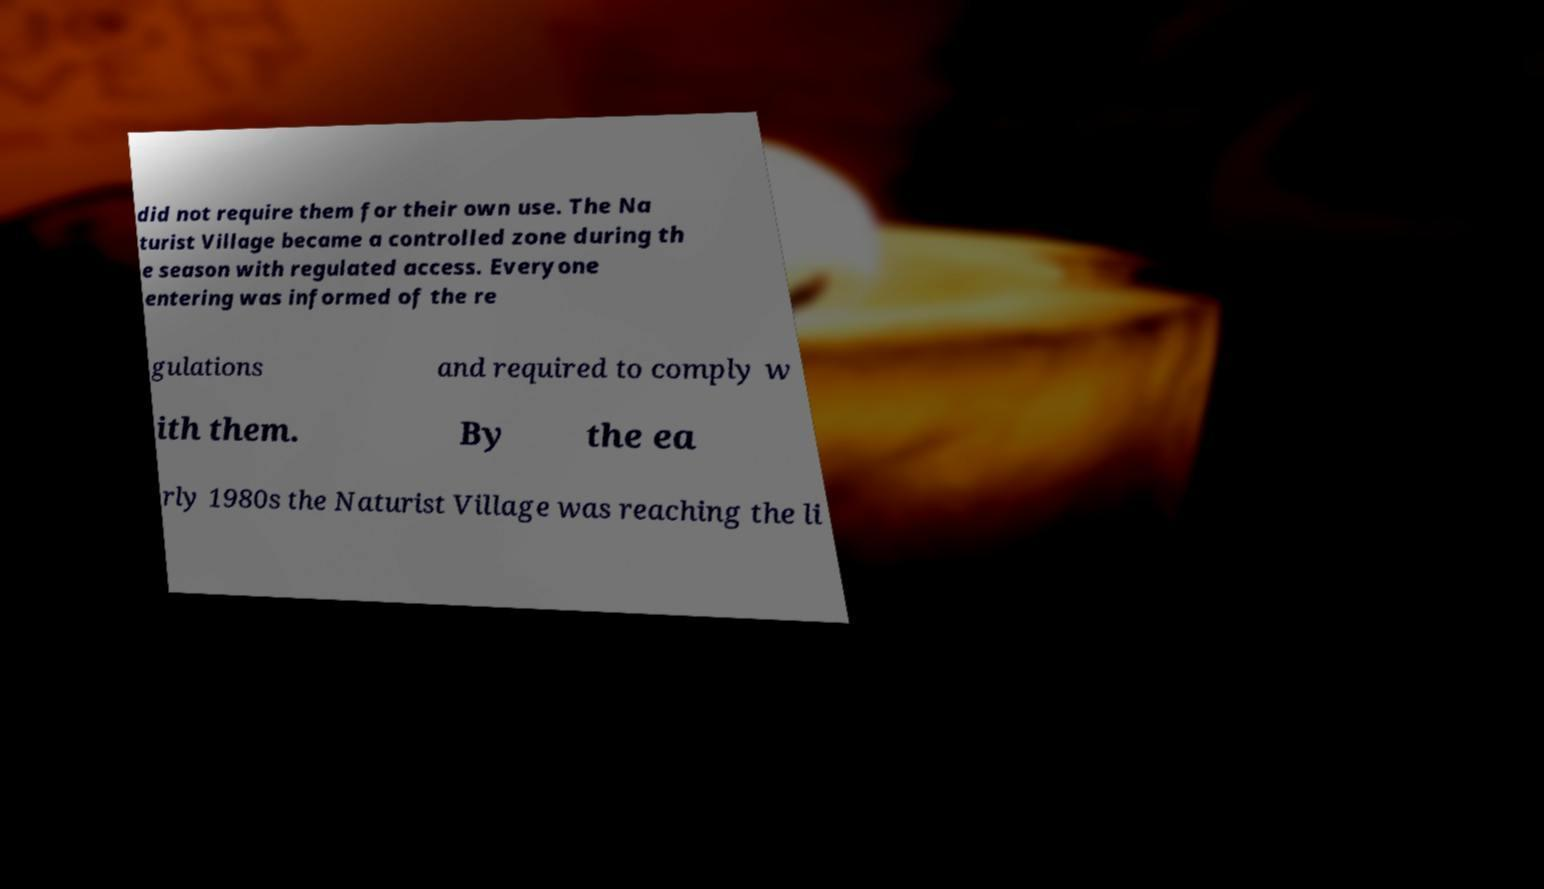Please read and relay the text visible in this image. What does it say? did not require them for their own use. The Na turist Village became a controlled zone during th e season with regulated access. Everyone entering was informed of the re gulations and required to comply w ith them. By the ea rly 1980s the Naturist Village was reaching the li 